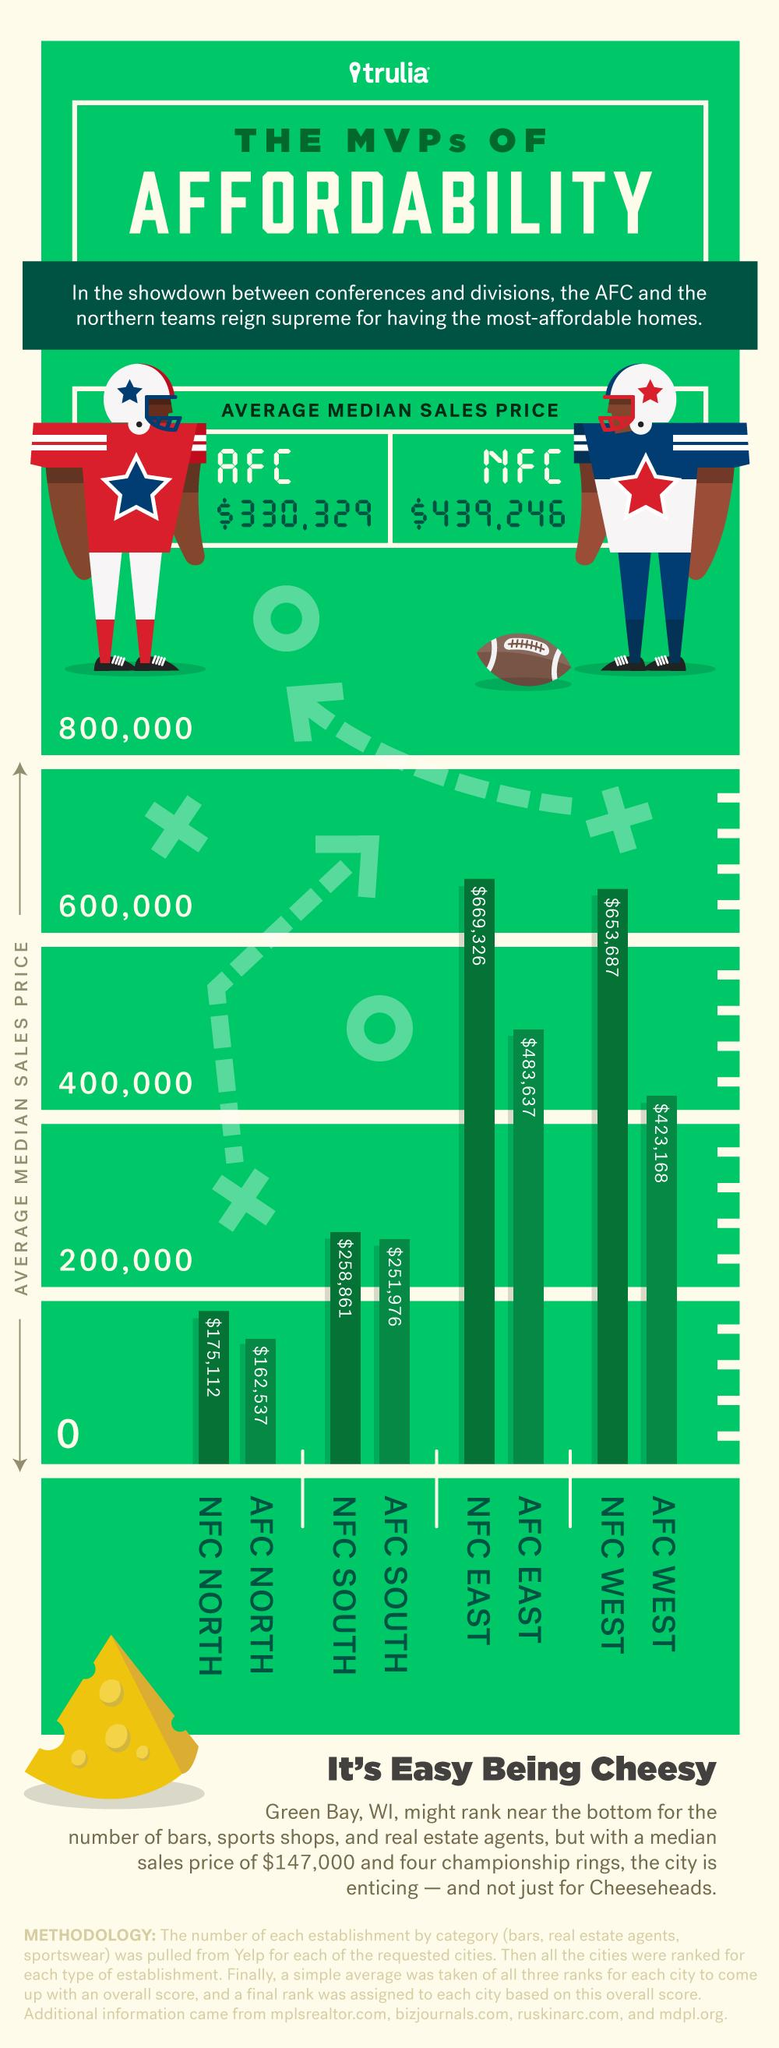Indicate a few pertinent items in this graphic. The AFC North Division has the lowest average median sales price among all the divisions in the American Football Conference. There are two NFC divisions with an average median sales price above $600,000. The average median sales price of properties in the NFC WEST is approximately $653,687. The average median sales price of the AFC WEST is $423,168. The NFC North division has the lowest median sales price among all four NFC divisions, with an average price of less than $200,000. 